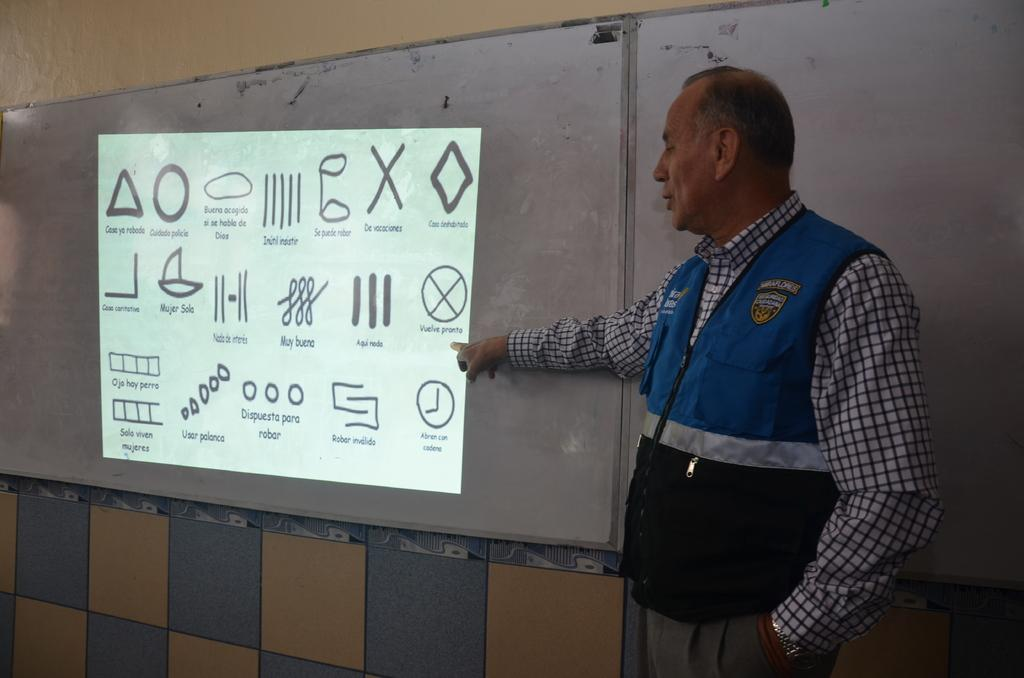What is present in the image? There is a man in the image. What can be seen in the background of the image? There is a board, a screen, and a wall in the background of the image. What book is the man holding in the image? There is no book present in the image. Can you touch the screen in the image? It is not possible to touch the screen in the image, as it is a two-dimensional representation. 